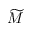<formula> <loc_0><loc_0><loc_500><loc_500>\widetilde { M }</formula> 